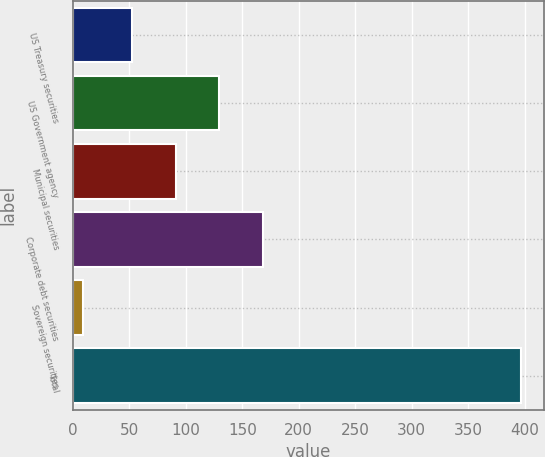Convert chart to OTSL. <chart><loc_0><loc_0><loc_500><loc_500><bar_chart><fcel>US Treasury securities<fcel>US Government agency<fcel>Municipal securities<fcel>Corporate debt securities<fcel>Sovereign securities<fcel>Total<nl><fcel>52<fcel>129.6<fcel>90.8<fcel>168.4<fcel>9<fcel>397<nl></chart> 